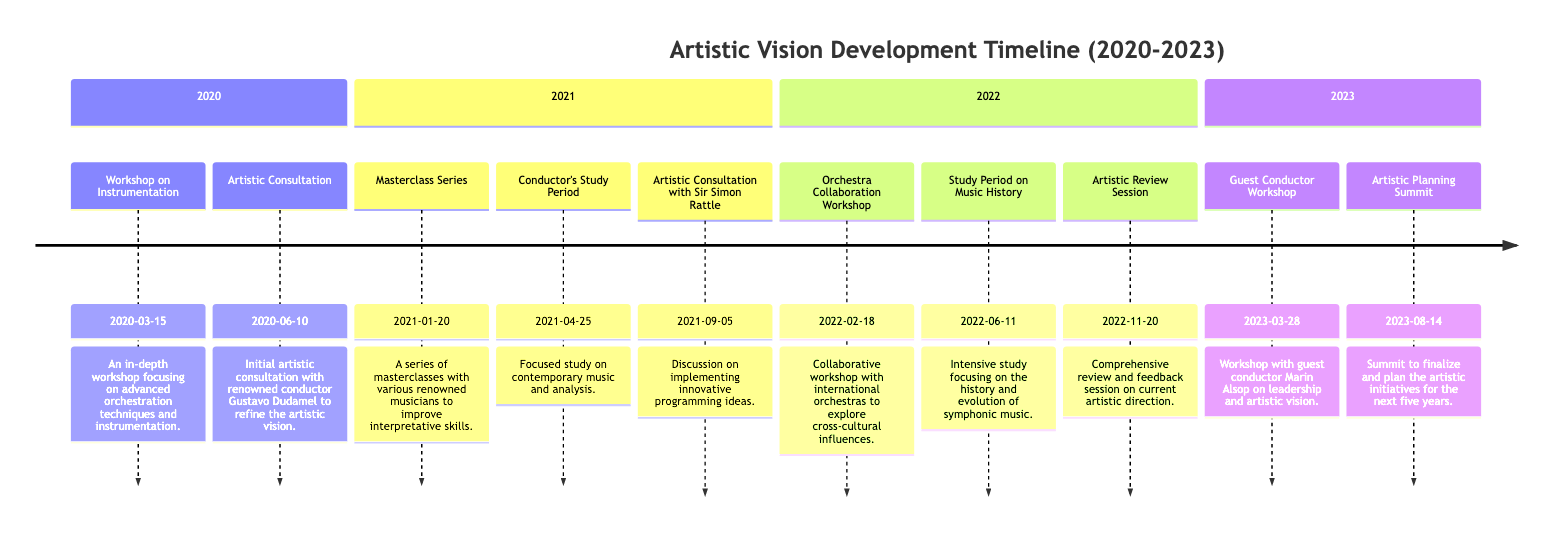What was the date of the Workshop on Instrumentation? The diagram shows that the Workshop on Instrumentation occurred on March 15, 2020. This date is listed directly next to the event in the timeline section for the year 2020.
Answer: March 15, 2020 Which location hosted the Masterclass Series? The Masterclass Series took place at the Royal College of Music, London. This information is provided alongside the event in the 2021 section of the diagram.
Answer: Royal College of Music, London How many events were held in 2022? In the year 2022, there were three events listed: the Orchestra Collaboration Workshop, Study Period on Music History, and Artistic Review Session. Thus, counting these events gives us a total of three for the year 2022.
Answer: 3 Who was the conductor consulted in 2021 for innovative programming ideas? The diagram indicates that the Artistic Consultation with Sir Simon Rattle took place on September 5, 2021. His name is associated with that specific consultation event.
Answer: Sir Simon Rattle What was the main focus during the Conductor's Study Period in 2021? The Conductor's Study Period in 2021 was focused on contemporary music and analysis, as clearly stated in the description next to that event in the timeline.
Answer: Contemporary music and analysis Which event serves as a comprehensive review session in 2022? The event that serves as a comprehensive review session in 2022 is the Artistic Review Session, which is explicitly stated in the timeline with its date.
Answer: Artistic Review Session What is the significance of the Artistic Planning Summit in 2023? The Artistic Planning Summit is significant for finalizing and planning artistic initiatives for the next five years, according to the description listed in the timeline under the year 2023.
Answer: Finalize and plan initiatives Which two workshops occurred in 2023? The two workshops that occurred in 2023 are the Guest Conductor Workshop in March and the Artistic Planning Summit in August, as specified in the timeline events for that year.
Answer: Guest Conductor Workshop and Artistic Planning Summit What was the location for the Orchestra Collaboration Workshop? The location for the Orchestra Collaboration Workshop, as indicated in the timeline, was the Berlin Philharmonic. This information is provided directly next to the event description.
Answer: Berlin Philharmonic 